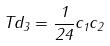Convert formula to latex. <formula><loc_0><loc_0><loc_500><loc_500>T d _ { 3 } = \frac { 1 } { 2 4 } c _ { 1 } c _ { 2 }</formula> 